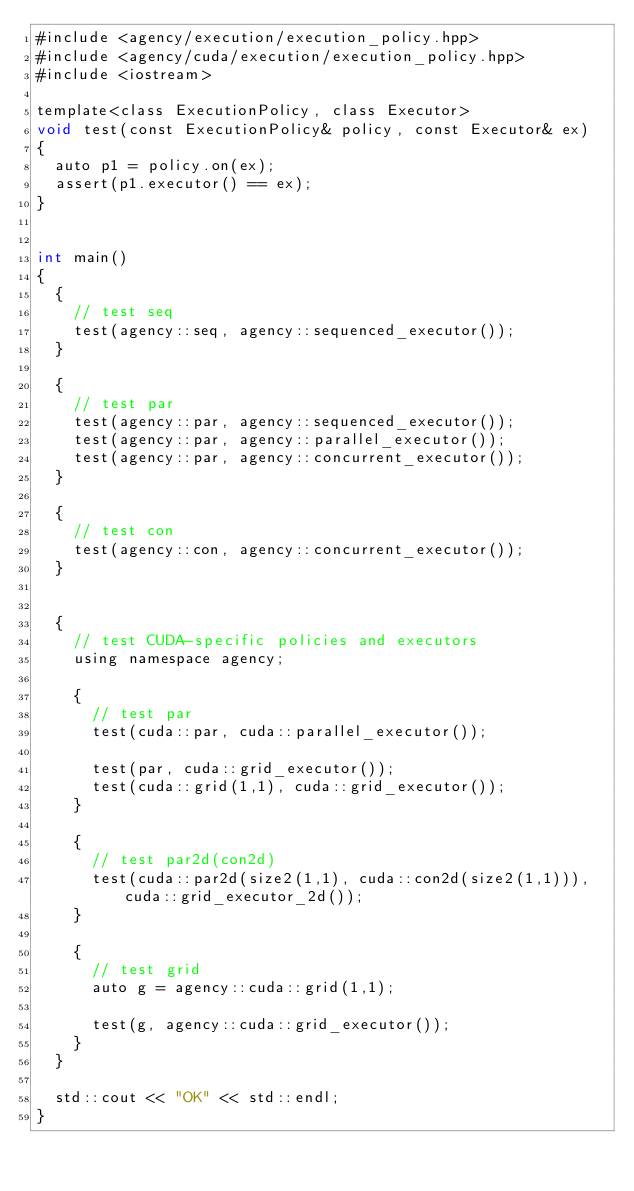Convert code to text. <code><loc_0><loc_0><loc_500><loc_500><_Cuda_>#include <agency/execution/execution_policy.hpp>
#include <agency/cuda/execution/execution_policy.hpp>
#include <iostream>

template<class ExecutionPolicy, class Executor>
void test(const ExecutionPolicy& policy, const Executor& ex)
{
  auto p1 = policy.on(ex);
  assert(p1.executor() == ex);
}


int main()
{
  {
    // test seq
    test(agency::seq, agency::sequenced_executor());
  }

  {
    // test par
    test(agency::par, agency::sequenced_executor());
    test(agency::par, agency::parallel_executor());
    test(agency::par, agency::concurrent_executor());
  }

  {
    // test con
    test(agency::con, agency::concurrent_executor());
  }


  {
    // test CUDA-specific policies and executors
    using namespace agency;

    {
      // test par
      test(cuda::par, cuda::parallel_executor());

      test(par, cuda::grid_executor());
      test(cuda::grid(1,1), cuda::grid_executor());
    }

    {
      // test par2d(con2d)
      test(cuda::par2d(size2(1,1), cuda::con2d(size2(1,1))), cuda::grid_executor_2d());
    }

    {
      // test grid
      auto g = agency::cuda::grid(1,1);

      test(g, agency::cuda::grid_executor());
    }
  }

  std::cout << "OK" << std::endl;
}

</code> 